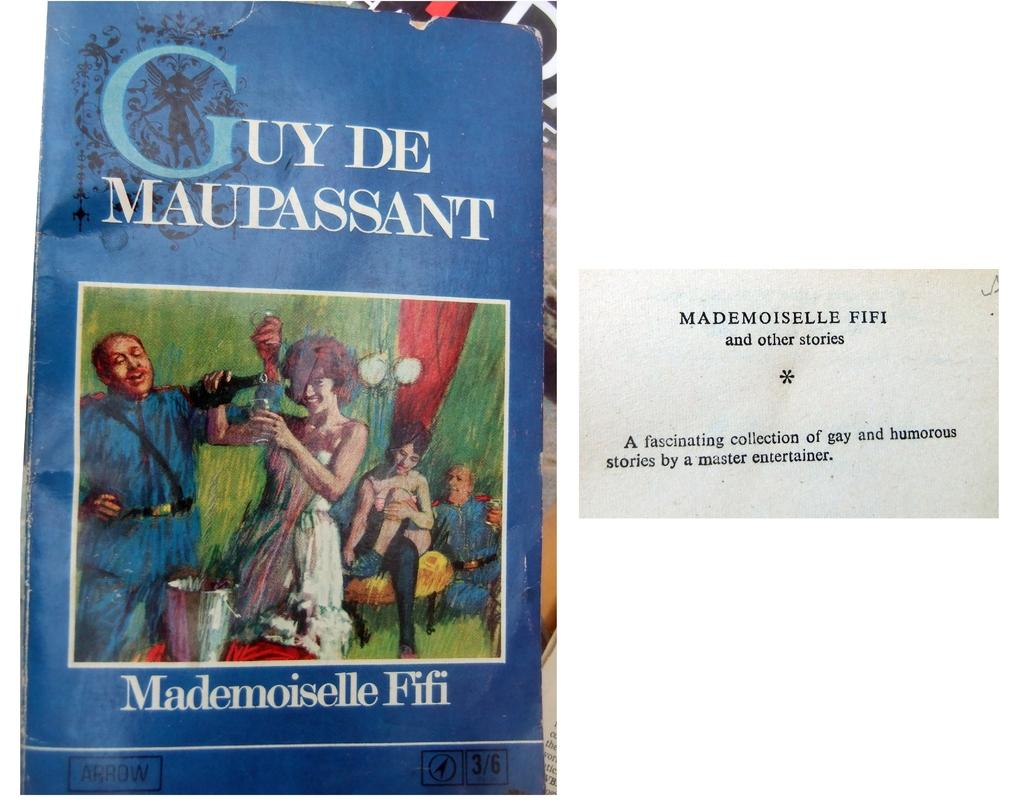<image>
Describe the image concisely. A blue book cover titled Guy De Maupassant. 